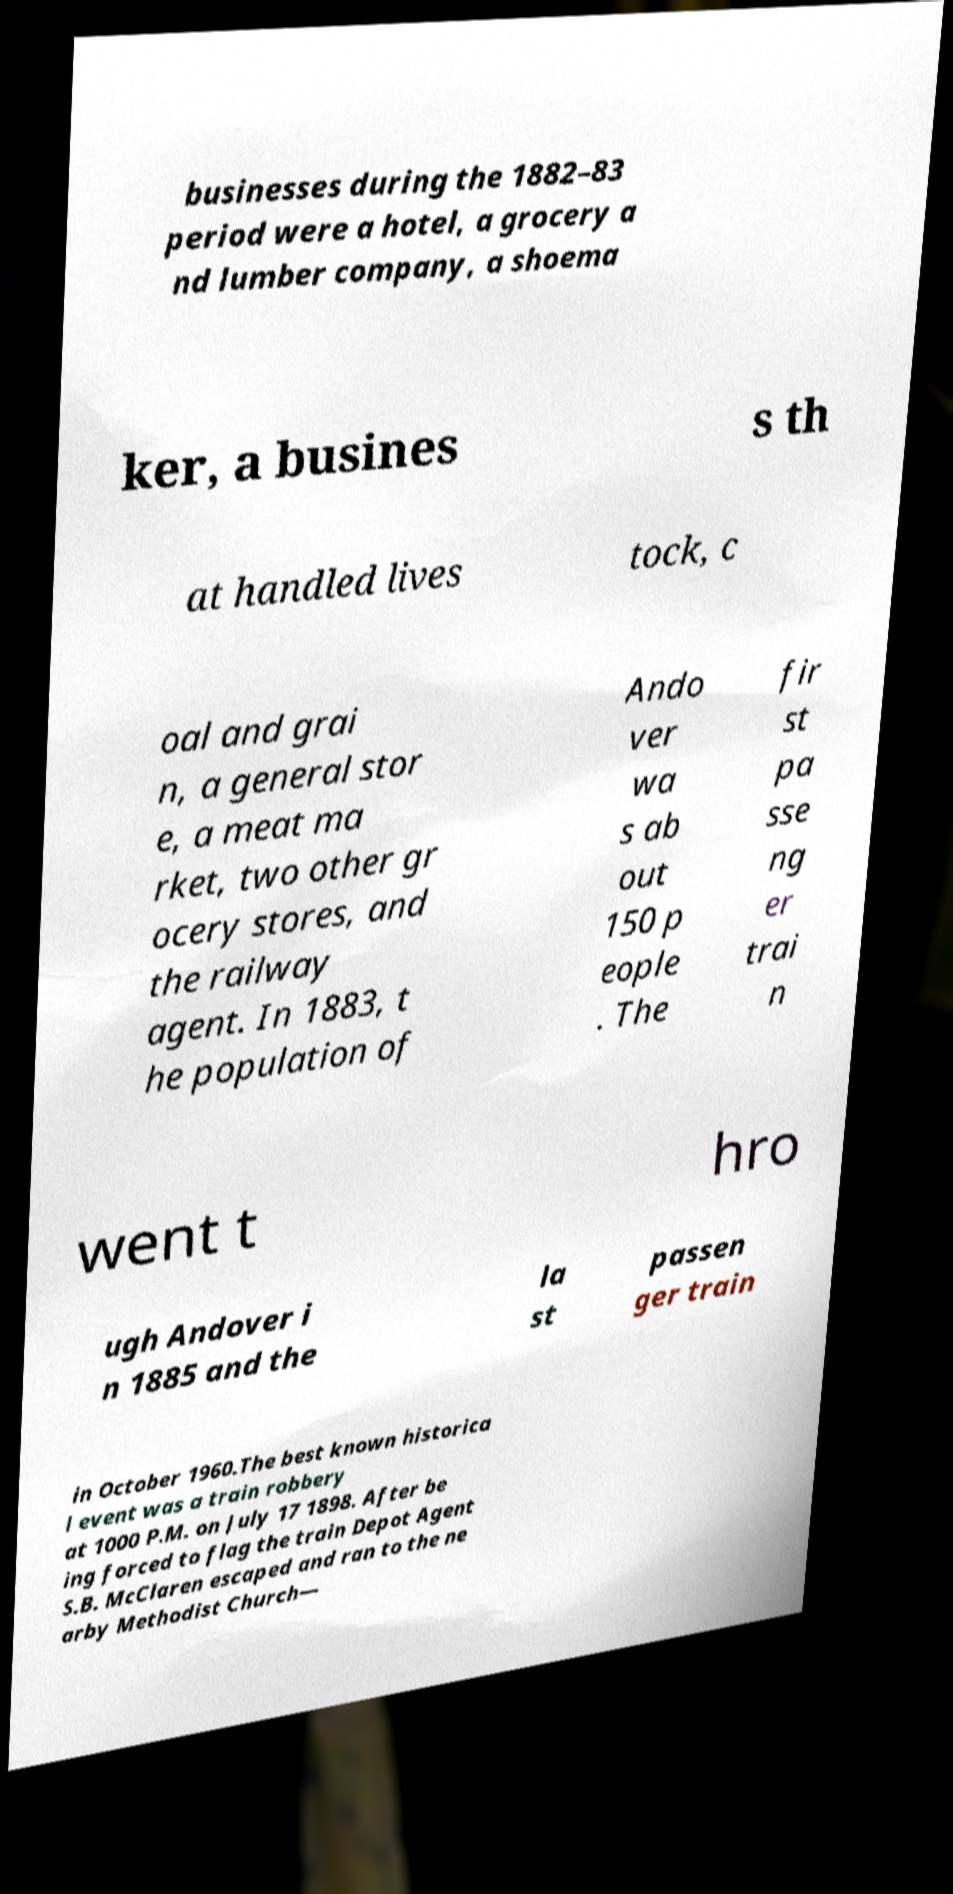Could you assist in decoding the text presented in this image and type it out clearly? businesses during the 1882–83 period were a hotel, a grocery a nd lumber company, a shoema ker, a busines s th at handled lives tock, c oal and grai n, a general stor e, a meat ma rket, two other gr ocery stores, and the railway agent. In 1883, t he population of Ando ver wa s ab out 150 p eople . The fir st pa sse ng er trai n went t hro ugh Andover i n 1885 and the la st passen ger train in October 1960.The best known historica l event was a train robbery at 1000 P.M. on July 17 1898. After be ing forced to flag the train Depot Agent S.B. McClaren escaped and ran to the ne arby Methodist Church— 